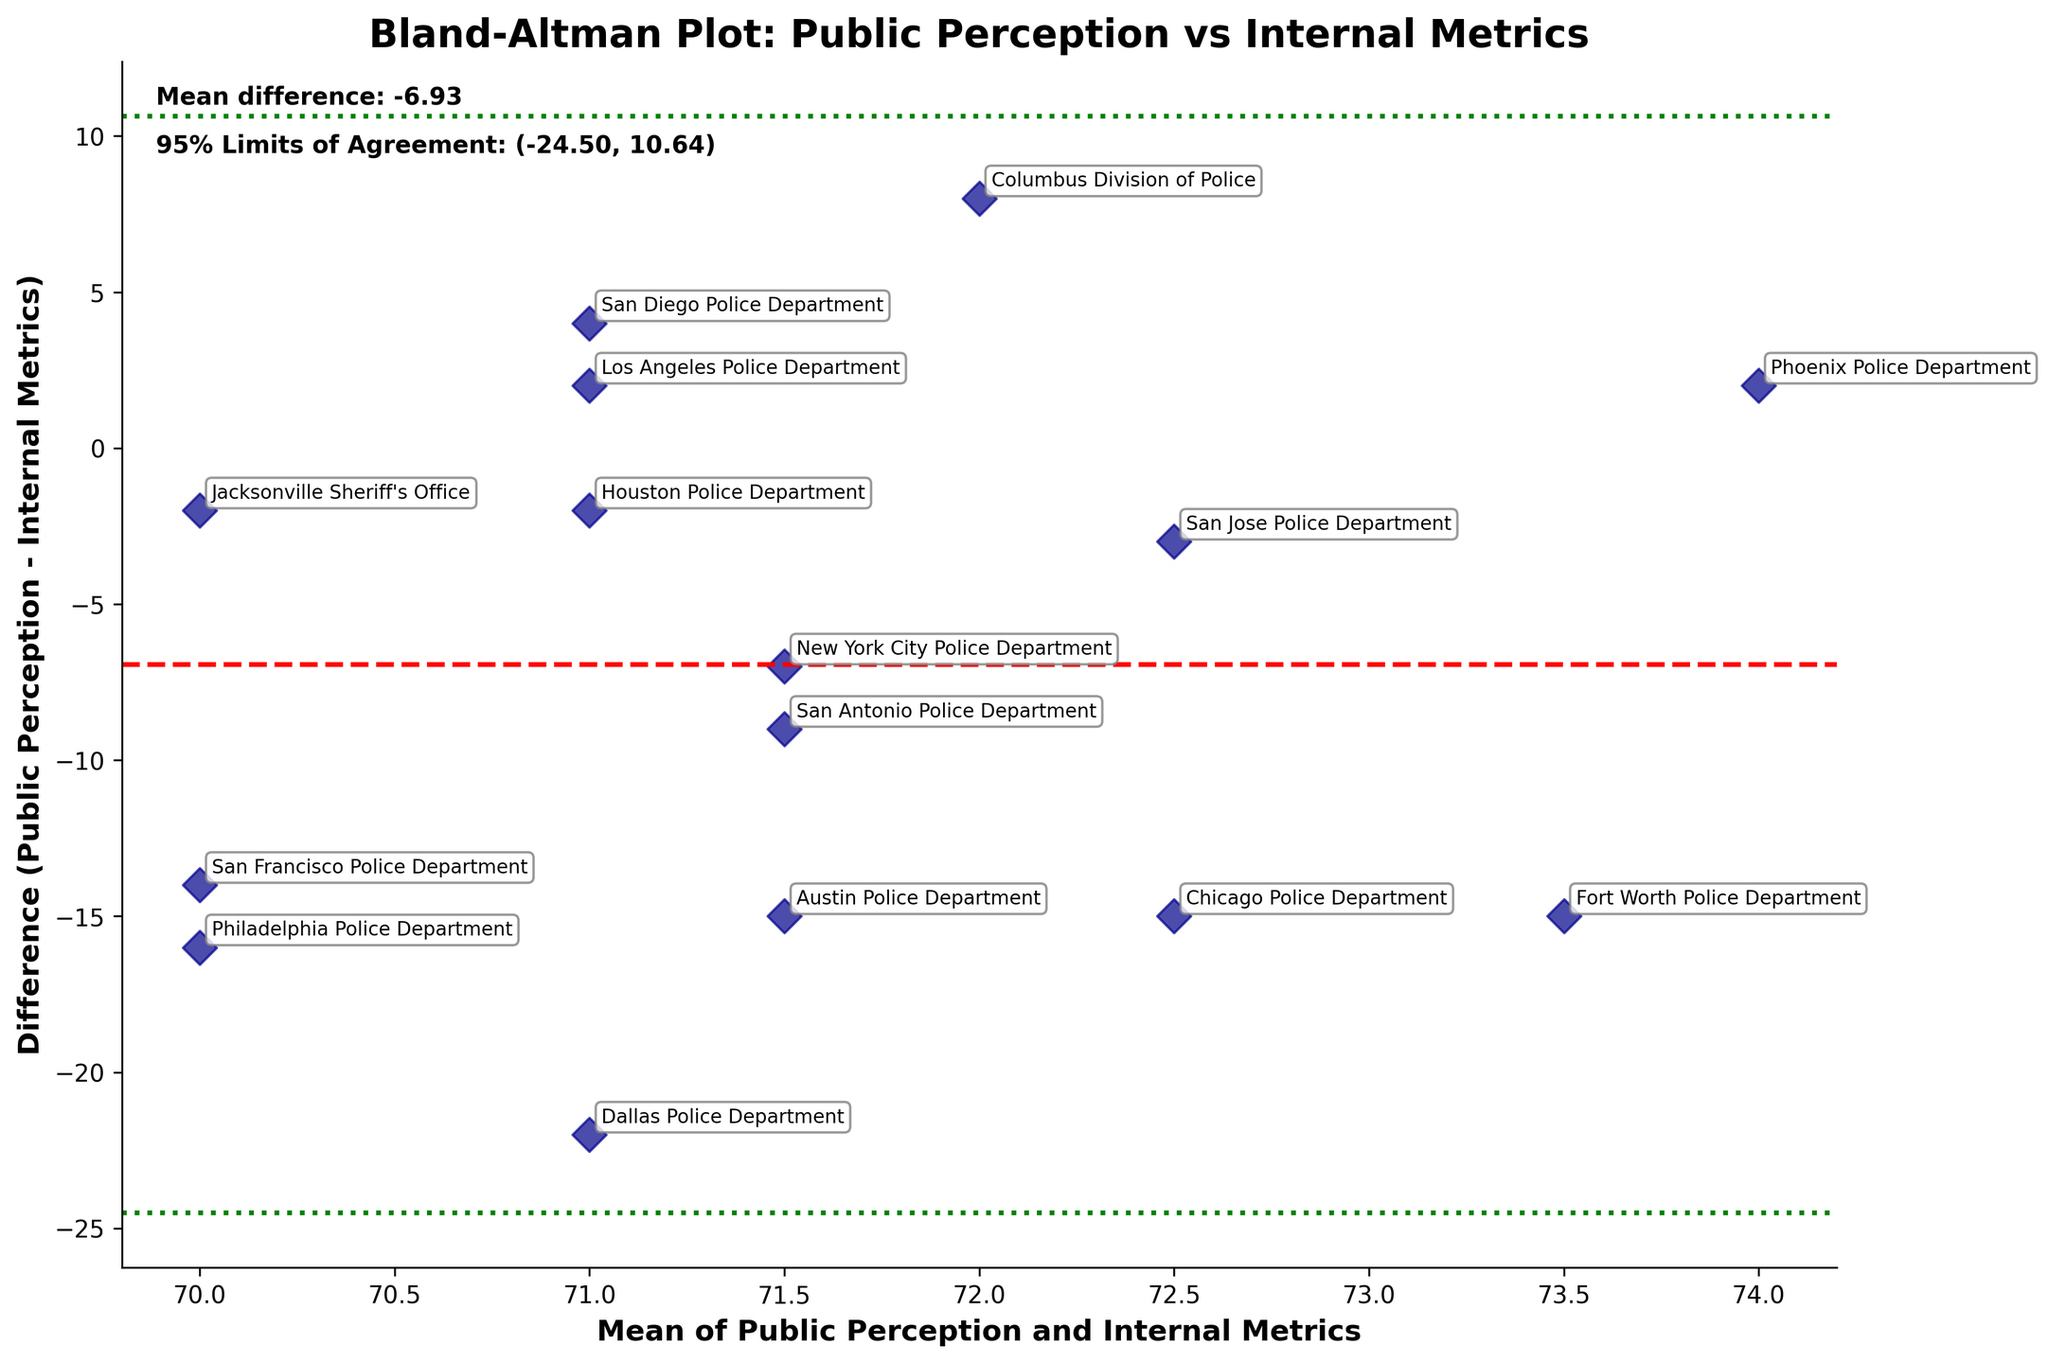What is the title of the plot? The title is usually displayed prominently at the top of the figure, summarizing the contents of the plot. In this plot, it is "Bland-Altman Plot: Public Perception vs Internal Metrics."
Answer: Bland-Altman Plot: Public Perception vs Internal Metrics What do the red and green lines represent on the plot? The red line represents the mean difference between public perception and internal metrics. The green lines represent the 95% limits of agreement, which are the mean difference plus and minus 1.96 times the standard deviation of the differences.
Answer: Red: Mean difference, Green: Limits of Agreement What is the mean difference between public perception and internal metrics? The mean difference is indicated by the red dashed line and also mentioned in the text on the plot. It is calculated as the average of the differences between public perception and internal metrics. In this plot, it is around -5.13.
Answer: -5.13 Which department has the largest positive difference between public perception and internal metrics? The largest positive difference is the highest point above the red dashed line. Upon examining the plot, the Dallas Police Department has the highest positive difference, where the y-value (difference) is +22.
Answer: Dallas Police Department What are the 95% limits of agreement? The plot shows green dashed lines indicating the 95% limits of agreement. These values are mentioned in the text on the plot as well, ranging from -13.71 to 3.45.
Answer: -13.71 to 3.45 How many data points fall outside the 95% limits of agreement? Data points that fall outside the 95% limits of agreement are those above the upper green line or below the lower green line. By observing the plot, we see that there are two such points: one for Dallas Police Department and one for Fort Worth Police Department.
Answer: 2 Which department has the mean value of public perception and internal metrics closest to 71? To find this, identify which point on the x-axis (which shows the mean value of public perception and internal metrics) is closest to 71. The Jacksonville Sheriff's Office is closest to this mean value.
Answer: Jacksonville Sheriff's Office What department has a negative difference closest to zero? A negative difference closest to zero would be the point nearest to the red dashed line on the lower side. The Houston Police Department (difference ~ -2) is closest to zero.
Answer: Houston Police Department How are the mean values of public perception and internal metrics calculated for each department? The mean value for each department is calculated by taking the average of public perception and internal metrics. For example, for the New York City Police Department, the mean value is (68+75)/2 = 71.5.
Answer: Average of the two values Which department has a difference (public perception - internal metrics) closest to -11? By examining the plot, we need to find the point near -11 on the y-axis. The Philadelphia Police Department has a difference value closest to -11, with ~ -16 being the observed difference.
Answer: Philadelphia Police Department 